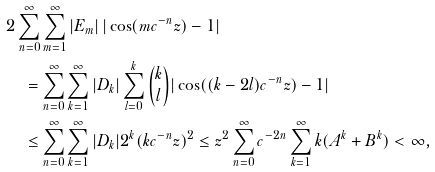Convert formula to latex. <formula><loc_0><loc_0><loc_500><loc_500>& 2 \sum _ { n = 0 } ^ { \infty } \sum _ { m = 1 } ^ { \infty } | E _ { m } | \, | \cos ( m c ^ { - n } z ) - 1 | \\ & \quad = \sum _ { n = 0 } ^ { \infty } \sum _ { k = 1 } ^ { \infty } | D _ { k } | \sum _ { l = 0 } ^ { k } \binom { k } { l } | \cos ( ( k - 2 l ) c ^ { - n } z ) - 1 | \\ & \quad \leq \sum _ { n = 0 } ^ { \infty } \sum _ { k = 1 } ^ { \infty } | D _ { k } | 2 ^ { k } ( k c ^ { - n } z ) ^ { 2 } \leq z ^ { 2 } \sum _ { n = 0 } ^ { \infty } c ^ { - 2 n } \sum _ { k = 1 } ^ { \infty } k ( A ^ { k } + B ^ { k } ) < \infty ,</formula> 